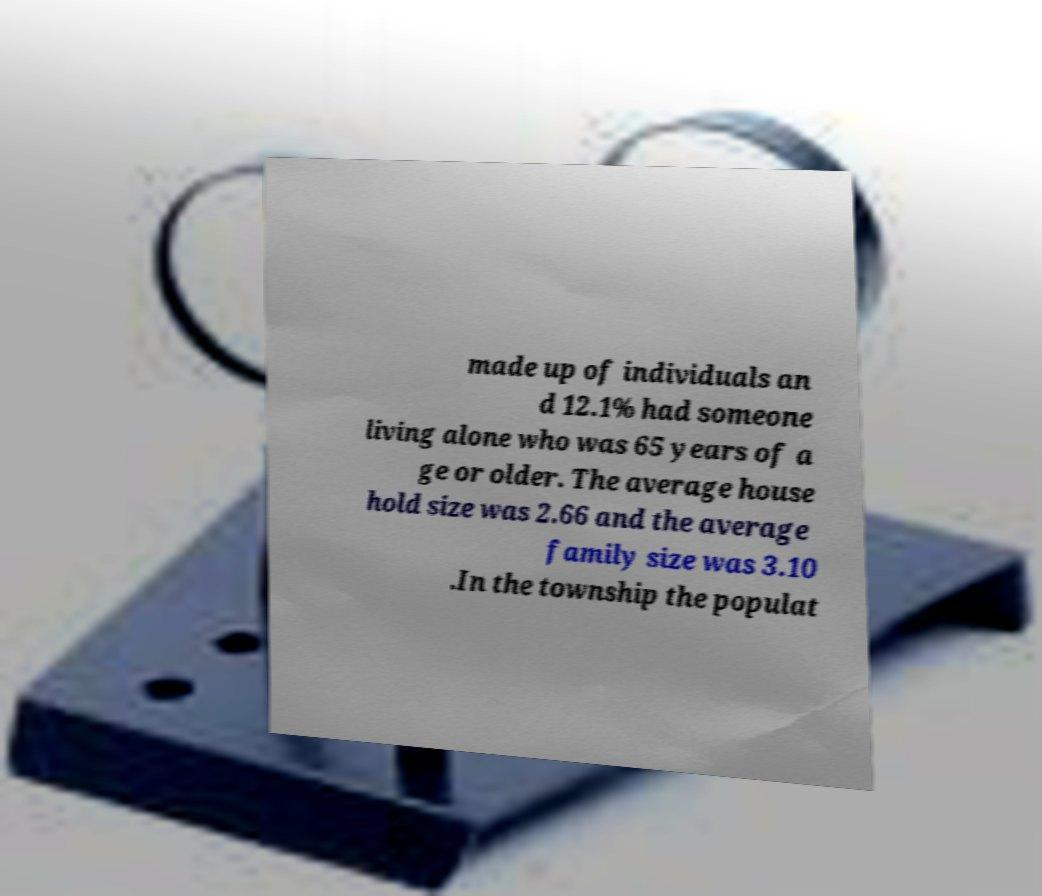Could you assist in decoding the text presented in this image and type it out clearly? made up of individuals an d 12.1% had someone living alone who was 65 years of a ge or older. The average house hold size was 2.66 and the average family size was 3.10 .In the township the populat 